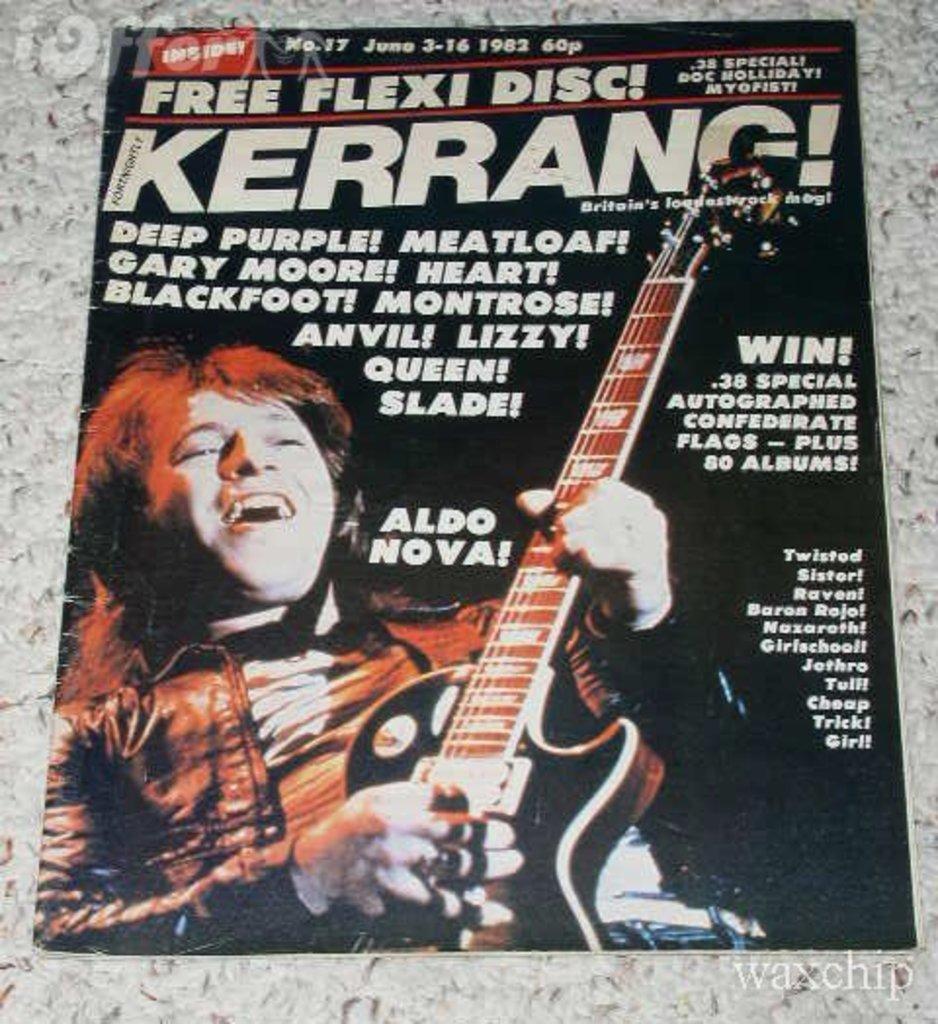Please provide a concise description of this image. In this image I can see the magazine. The person is holding guitar and something is written on it. Magazine is on the grey surface. 